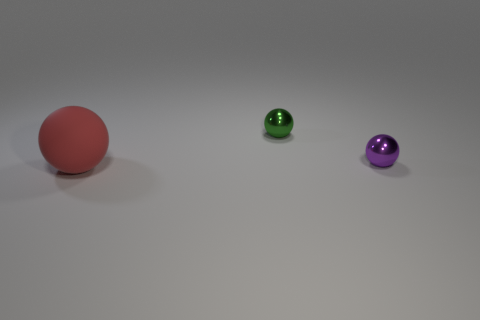Add 1 small blue rubber spheres. How many objects exist? 4 Subtract 1 green spheres. How many objects are left? 2 Subtract all small purple shiny balls. Subtract all small purple spheres. How many objects are left? 1 Add 1 purple metallic spheres. How many purple metallic spheres are left? 2 Add 3 small yellow balls. How many small yellow balls exist? 3 